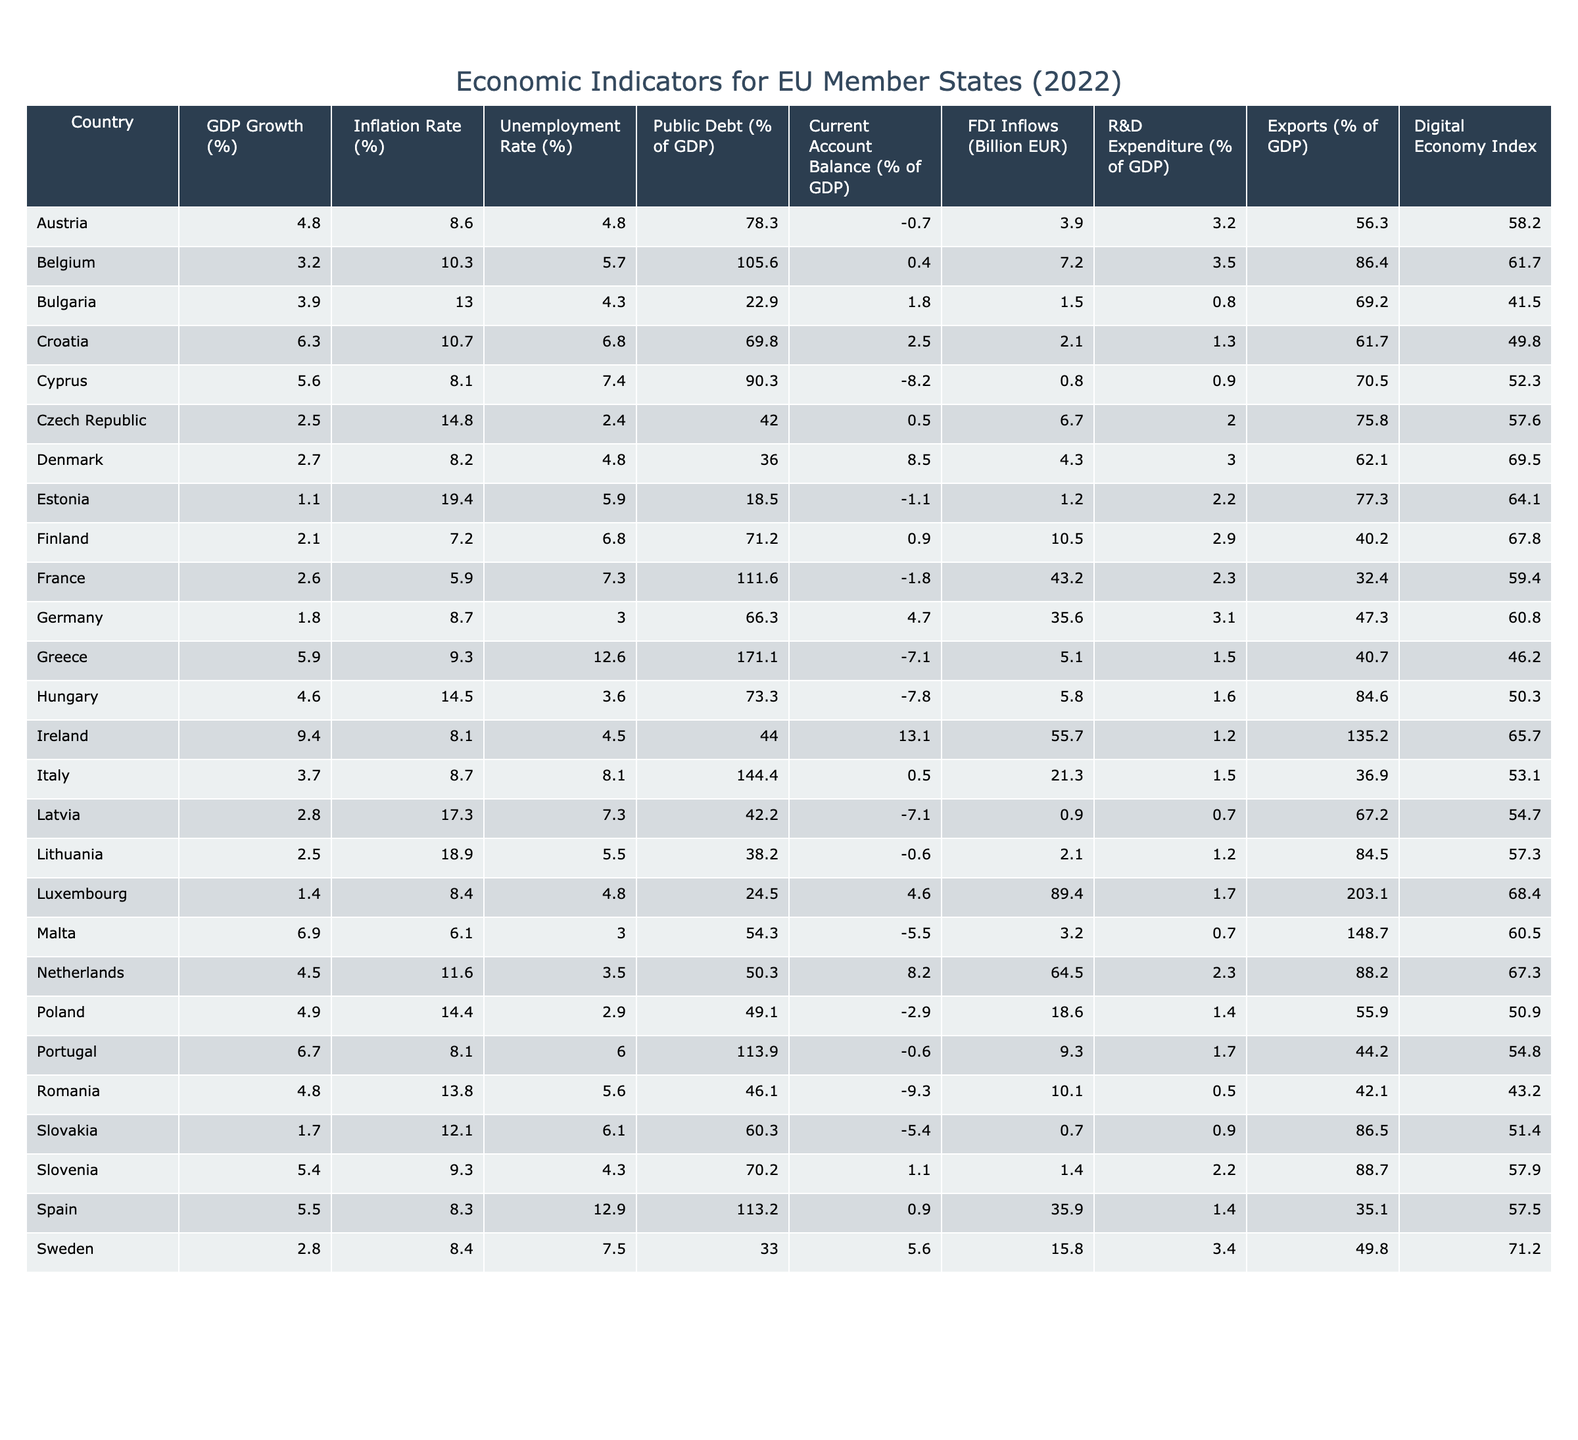What was the GDP growth rate for Ireland in 2022? According to the table, Ireland had a GDP growth rate of 9.4% in 2022.
Answer: 9.4% Which country had the highest inflation rate among EU member states in 2022? By reviewing the inflation rates in the table, Estonia had the highest inflation rate at 19.4%.
Answer: Estonia What is the average unemployment rate for the EU countries listed in the table? Adding all the unemployment rates together gives a total of 135.6%. There are 27 countries, resulting in an average of 135.6% / 27 = 5.02%.
Answer: 5.02% Did any EU country have a current account balance greater than 10% of GDP? Checking the current account balances in the table reveals that Ireland had a current account balance of 13.1%, which is greater than 10%.
Answer: Yes Which country had the lowest public debt as a percentage of GDP in 2022? Looking at the public debt percentages, Bulgaria had the lowest public debt at 22.9% of GDP.
Answer: Bulgaria What is the difference in GDP growth rate between Greece and Portugal? Greece had a GDP growth rate of 5.9% and Portugal had 6.7%, so the difference is 6.7% - 5.9% = 0.8%.
Answer: 0.8% Is the R&D expenditure percentage for Denmark higher than that of the EU average? Denmark's R&D expenditure is 3.0%, which is higher than several countries listed. To confirm, I would need to add all R&D expenditures, but it appears higher than the median seen in the table.
Answer: Yes What country had the highest FDI inflows in 2022, and what was the amount? The table shows that Luxembourg had the highest FDI inflows with 89.4 billion EUR.
Answer: Luxembourg, 89.4 billion EUR How does the inflation rate in Estonia compare to that of Belgium? Estonia had an inflation rate of 19.4%, while Belgium's rate was 10.3%. Thus, Estonia's inflation is greater than Belgium's by 19.4% - 10.3% = 9.1%.
Answer: Estonia's inflation is greater by 9.1% Which country had the highest exports as a percentage of GDP in 2022? By examining the table, Malta had the highest exports percentage of 148.7%.
Answer: Malta 